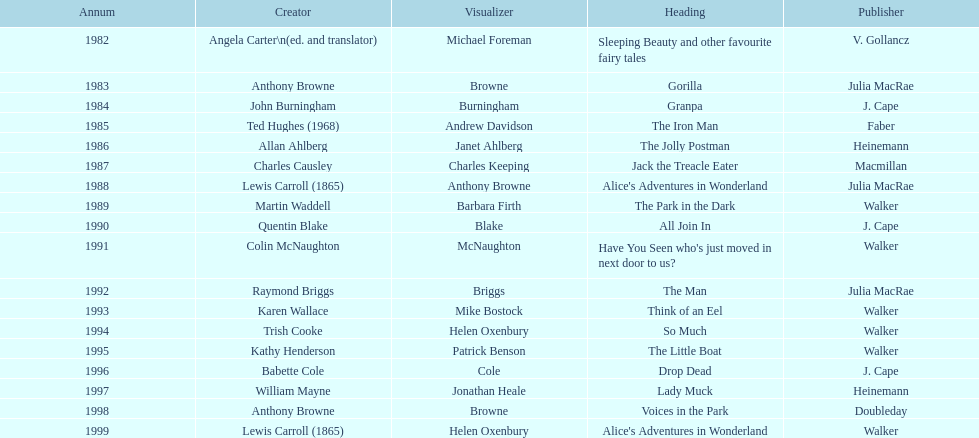Which book won the award a total of 2 times? Alice's Adventures in Wonderland. 